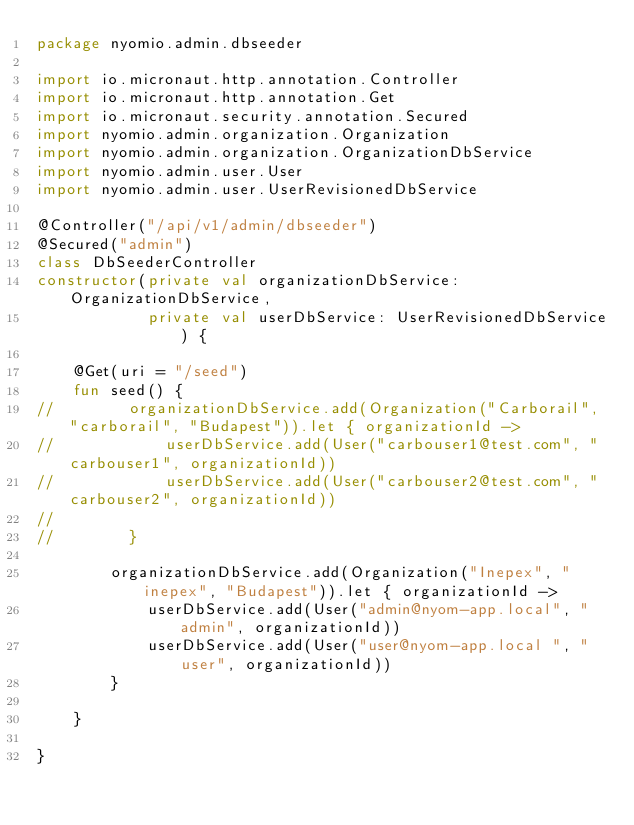<code> <loc_0><loc_0><loc_500><loc_500><_Kotlin_>package nyomio.admin.dbseeder

import io.micronaut.http.annotation.Controller
import io.micronaut.http.annotation.Get
import io.micronaut.security.annotation.Secured
import nyomio.admin.organization.Organization
import nyomio.admin.organization.OrganizationDbService
import nyomio.admin.user.User
import nyomio.admin.user.UserRevisionedDbService

@Controller("/api/v1/admin/dbseeder")
@Secured("admin")
class DbSeederController
constructor(private val organizationDbService: OrganizationDbService,
            private val userDbService: UserRevisionedDbService) {

    @Get(uri = "/seed")
    fun seed() {
//        organizationDbService.add(Organization("Carborail", "carborail", "Budapest")).let { organizationId ->
//            userDbService.add(User("carbouser1@test.com", "carbouser1", organizationId))
//            userDbService.add(User("carbouser2@test.com", "carbouser2", organizationId))
//
//        }

        organizationDbService.add(Organization("Inepex", "inepex", "Budapest")).let { organizationId ->
            userDbService.add(User("admin@nyom-app.local", "admin", organizationId))
            userDbService.add(User("user@nyom-app.local	", "user", organizationId))
        }

    }

}
</code> 